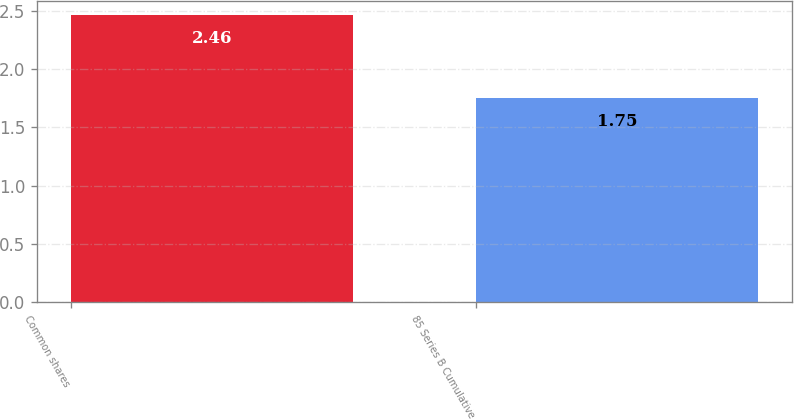Convert chart. <chart><loc_0><loc_0><loc_500><loc_500><bar_chart><fcel>Common shares<fcel>85 Series B Cumulative<nl><fcel>2.46<fcel>1.75<nl></chart> 